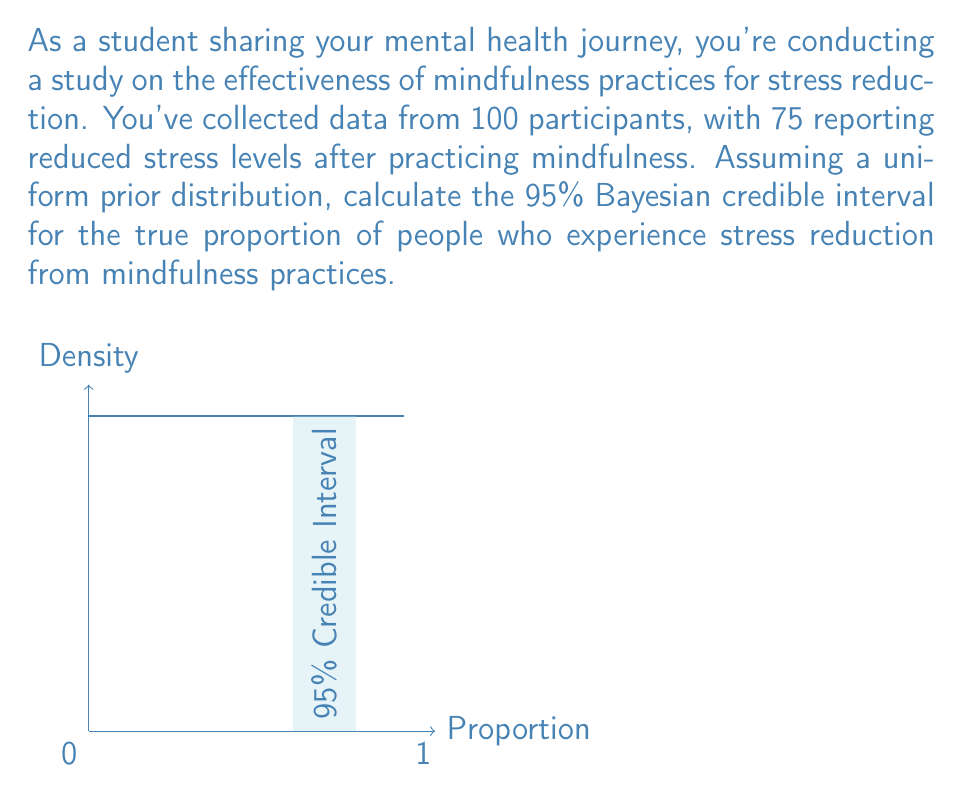What is the answer to this math problem? Let's approach this step-by-step using Bayesian analysis:

1) The likelihood function follows a Binomial distribution:
   $$ L(\theta|x) \propto \theta^x (1-\theta)^{n-x} $$
   where $\theta$ is the proportion of people experiencing stress reduction, $x=75$ (successes), and $n=100$ (total participants).

2) With a uniform prior $Beta(1,1)$, the posterior distribution is:
   $$ p(\theta|x) \propto \theta^{75} (1-\theta)^{25} $$
   This is a $Beta(76,26)$ distribution.

3) The parameters of the posterior Beta distribution are:
   $\alpha = 76$ and $\beta = 26$

4) For a 95% credible interval, we need to find the 2.5th and 97.5th percentiles of this Beta distribution.

5) We can use the inverse cumulative distribution function (quantile function) of the Beta distribution:
   $$ q_{low} = Beta^{-1}(0.025, 76, 26) $$
   $$ q_{high} = Beta^{-1}(0.975, 76, 26) $$

6) Calculating these values (using statistical software or tables):
   $q_{low} \approx 0.6524$
   $q_{high} \approx 0.8325$

Therefore, the 95% Bayesian credible interval is approximately (0.6524, 0.8325).
Answer: (0.6524, 0.8325) 